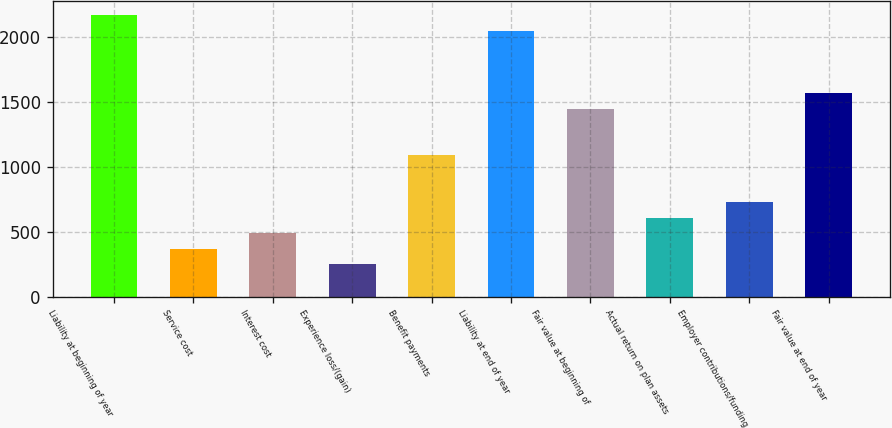<chart> <loc_0><loc_0><loc_500><loc_500><bar_chart><fcel>Liability at beginning of year<fcel>Service cost<fcel>Interest cost<fcel>Experience loss/(gain)<fcel>Benefit payments<fcel>Liability at end of year<fcel>Fair value at beginning of<fcel>Actual return on plan assets<fcel>Employer contributions/funding<fcel>Fair value at end of year<nl><fcel>2167.2<fcel>368.7<fcel>488.6<fcel>248.8<fcel>1088.1<fcel>2047.3<fcel>1447.8<fcel>608.5<fcel>728.4<fcel>1567.7<nl></chart> 